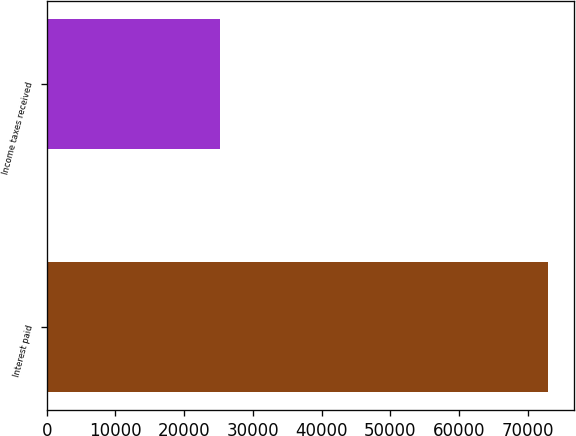Convert chart to OTSL. <chart><loc_0><loc_0><loc_500><loc_500><bar_chart><fcel>Interest paid<fcel>Income taxes received<nl><fcel>73031<fcel>25202<nl></chart> 